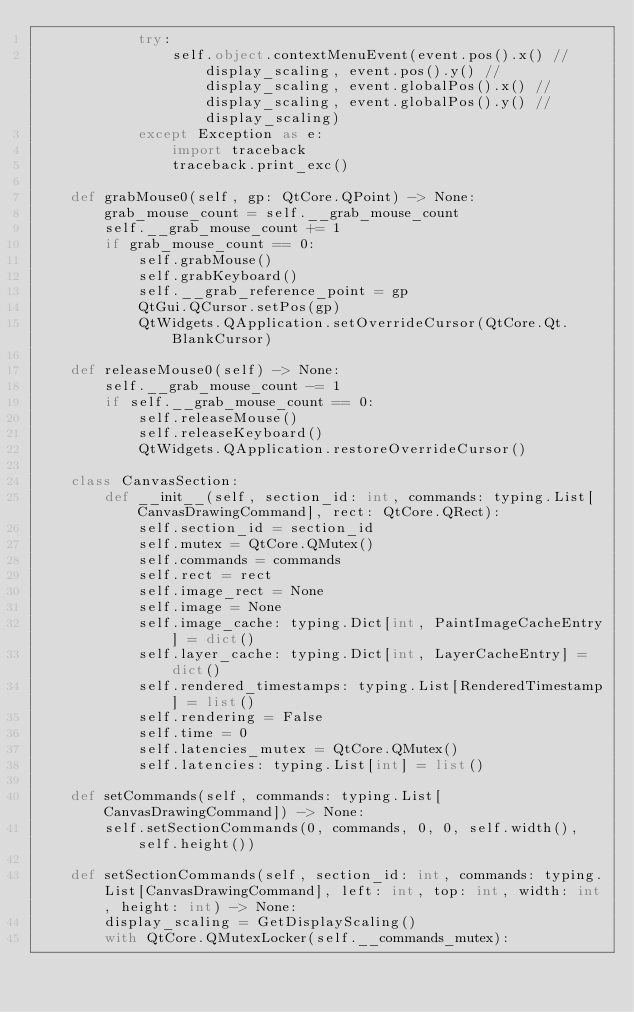<code> <loc_0><loc_0><loc_500><loc_500><_Python_>            try:
                self.object.contextMenuEvent(event.pos().x() // display_scaling, event.pos().y() // display_scaling, event.globalPos().x() // display_scaling, event.globalPos().y() // display_scaling)
            except Exception as e:
                import traceback
                traceback.print_exc()

    def grabMouse0(self, gp: QtCore.QPoint) -> None:
        grab_mouse_count = self.__grab_mouse_count
        self.__grab_mouse_count += 1
        if grab_mouse_count == 0:
            self.grabMouse()
            self.grabKeyboard()
            self.__grab_reference_point = gp
            QtGui.QCursor.setPos(gp)
            QtWidgets.QApplication.setOverrideCursor(QtCore.Qt.BlankCursor)

    def releaseMouse0(self) -> None:
        self.__grab_mouse_count -= 1
        if self.__grab_mouse_count == 0:
            self.releaseMouse()
            self.releaseKeyboard()
            QtWidgets.QApplication.restoreOverrideCursor()

    class CanvasSection:
        def __init__(self, section_id: int, commands: typing.List[CanvasDrawingCommand], rect: QtCore.QRect):
            self.section_id = section_id
            self.mutex = QtCore.QMutex()
            self.commands = commands
            self.rect = rect
            self.image_rect = None
            self.image = None
            self.image_cache: typing.Dict[int, PaintImageCacheEntry] = dict()
            self.layer_cache: typing.Dict[int, LayerCacheEntry] = dict()
            self.rendered_timestamps: typing.List[RenderedTimestamp] = list()
            self.rendering = False
            self.time = 0
            self.latencies_mutex = QtCore.QMutex()
            self.latencies: typing.List[int] = list()

    def setCommands(self, commands: typing.List[CanvasDrawingCommand]) -> None:
        self.setSectionCommands(0, commands, 0, 0, self.width(), self.height())

    def setSectionCommands(self, section_id: int, commands: typing.List[CanvasDrawingCommand], left: int, top: int, width: int, height: int) -> None:
        display_scaling = GetDisplayScaling()
        with QtCore.QMutexLocker(self.__commands_mutex):</code> 